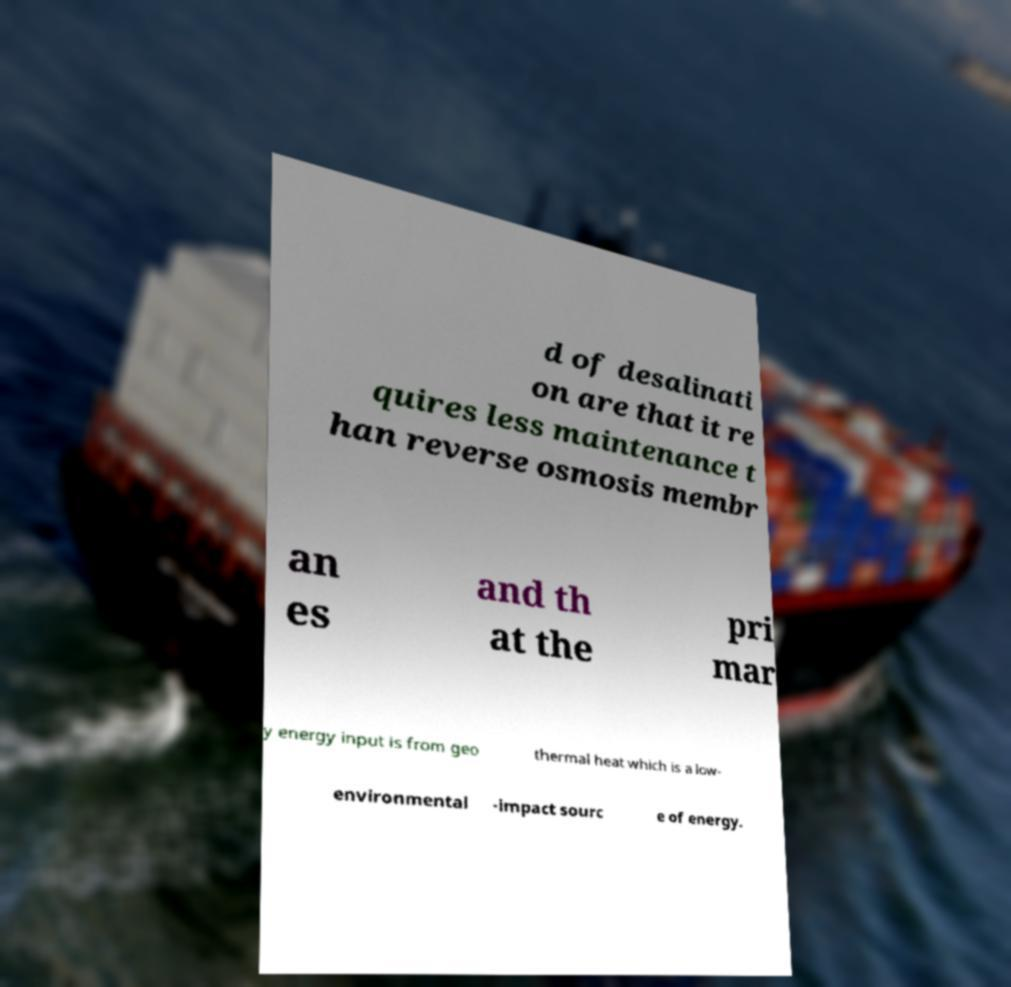I need the written content from this picture converted into text. Can you do that? d of desalinati on are that it re quires less maintenance t han reverse osmosis membr an es and th at the pri mar y energy input is from geo thermal heat which is a low- environmental -impact sourc e of energy. 